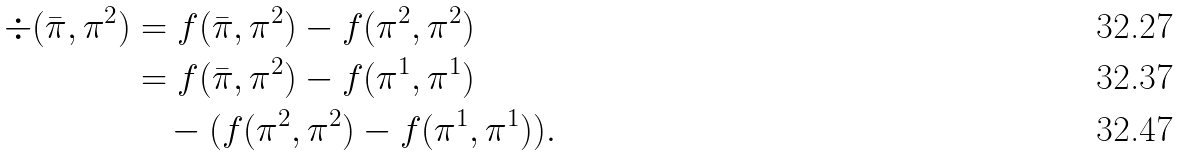Convert formula to latex. <formula><loc_0><loc_0><loc_500><loc_500>\div ( \bar { \pi } , \pi ^ { 2 } ) & = f ( \bar { \pi } , \pi ^ { 2 } ) - f ( \pi ^ { 2 } , \pi ^ { 2 } ) \\ & = f ( \bar { \pi } , \pi ^ { 2 } ) - f ( \pi ^ { 1 } , \pi ^ { 1 } ) \\ & \quad - ( f ( \pi ^ { 2 } , \pi ^ { 2 } ) - f ( \pi ^ { 1 } , \pi ^ { 1 } ) ) .</formula> 